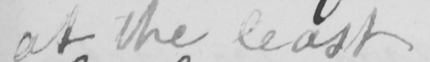What does this handwritten line say? at the least . 